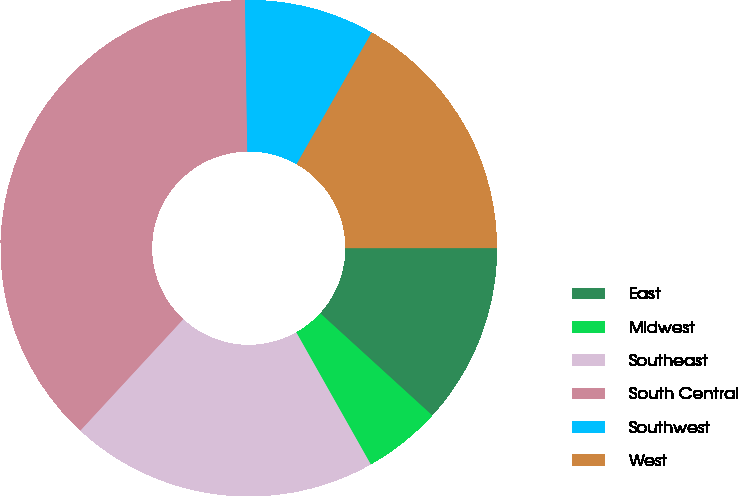Convert chart to OTSL. <chart><loc_0><loc_0><loc_500><loc_500><pie_chart><fcel>East<fcel>Midwest<fcel>Southeast<fcel>South Central<fcel>Southwest<fcel>West<nl><fcel>11.77%<fcel>5.06%<fcel>20.04%<fcel>37.89%<fcel>8.48%<fcel>16.75%<nl></chart> 